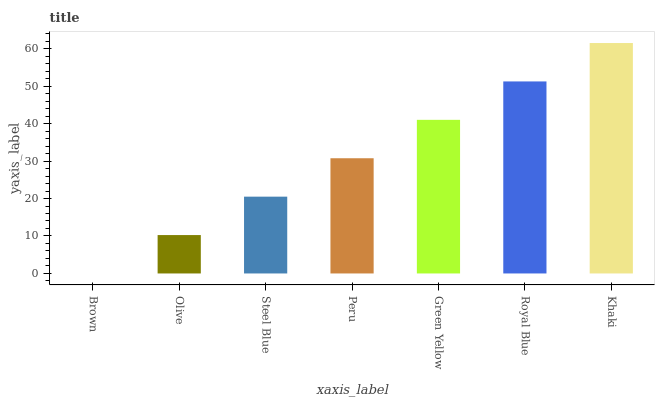Is Brown the minimum?
Answer yes or no. Yes. Is Khaki the maximum?
Answer yes or no. Yes. Is Olive the minimum?
Answer yes or no. No. Is Olive the maximum?
Answer yes or no. No. Is Olive greater than Brown?
Answer yes or no. Yes. Is Brown less than Olive?
Answer yes or no. Yes. Is Brown greater than Olive?
Answer yes or no. No. Is Olive less than Brown?
Answer yes or no. No. Is Peru the high median?
Answer yes or no. Yes. Is Peru the low median?
Answer yes or no. Yes. Is Green Yellow the high median?
Answer yes or no. No. Is Royal Blue the low median?
Answer yes or no. No. 